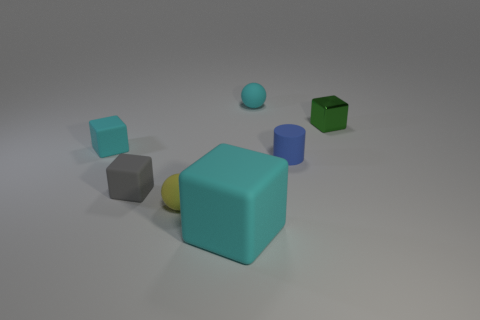Add 1 blue matte cylinders. How many objects exist? 8 Subtract all balls. How many objects are left? 5 Subtract all rubber things. Subtract all gray metal blocks. How many objects are left? 1 Add 2 tiny yellow rubber balls. How many tiny yellow rubber balls are left? 3 Add 7 big cyan rubber cubes. How many big cyan rubber cubes exist? 8 Subtract 0 blue spheres. How many objects are left? 7 